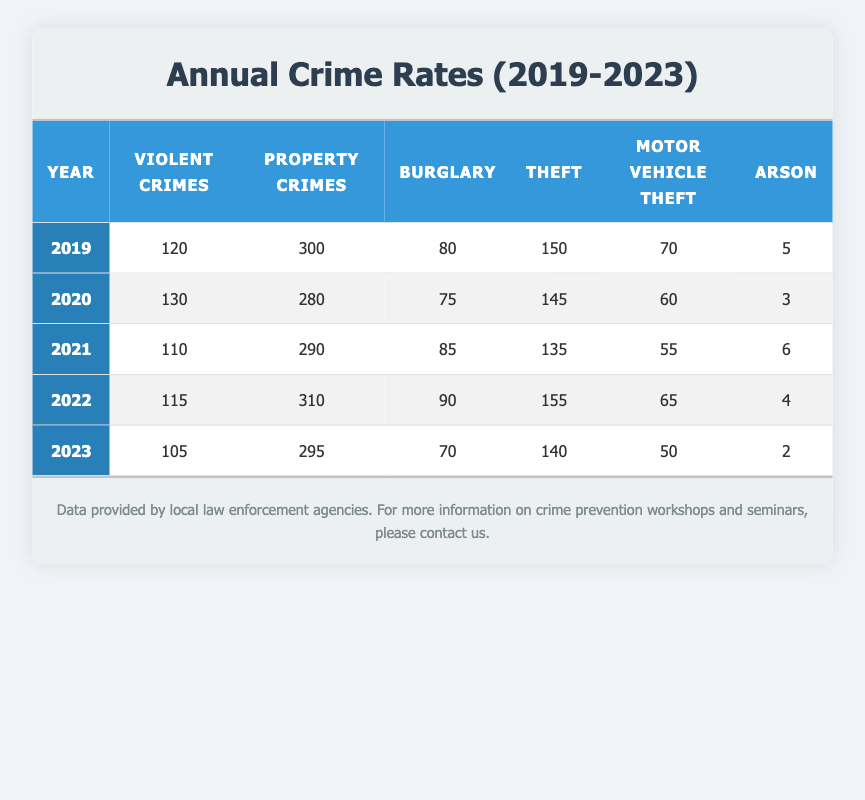What was the total number of violent crimes reported in 2020? In the table, the number of violent crimes for the year 2020 is specifically mentioned as 130. Therefore, that is the total reported for that year.
Answer: 130 What is the year with the highest number of property crimes? By reviewing the property crimes column, 310 is the highest number found, which corresponds to the year 2022. Thus, 2022 is the year with the highest property crimes.
Answer: 2022 What is the difference in the number of thefts between 2019 and 2023? From the table, thefts were 150 in 2019 and 140 in 2023. The difference is calculated as 150 - 140 = 10.
Answer: 10 In which year did the community experience the lowest number of motor vehicle thefts? The motor vehicle thefts were 70 in 2019, 60 in 2020, 55 in 2021, 65 in 2022, and 50 in 2023. The lowest number is 50 in 2023.
Answer: 2023 Was there a decrease in the number of arsons from 2019 to 2023? The arson counts from the years 2019 to 2023 are 5, 3, 6, 4, and 2 respectively. From 2019 to 2023, the counts show a decrease, as the number dropped from 5 to 2.
Answer: Yes What is the average number of violent crimes between 2019 and 2023? The violent crime counts from 2019 (120), 2020 (130), 2021 (110), 2022 (115), and 2023 (105) give a total of 120 + 130 + 110 + 115 + 105 = 580. The average is then calculated as 580 divided by 5, which equals 116.
Answer: 116 